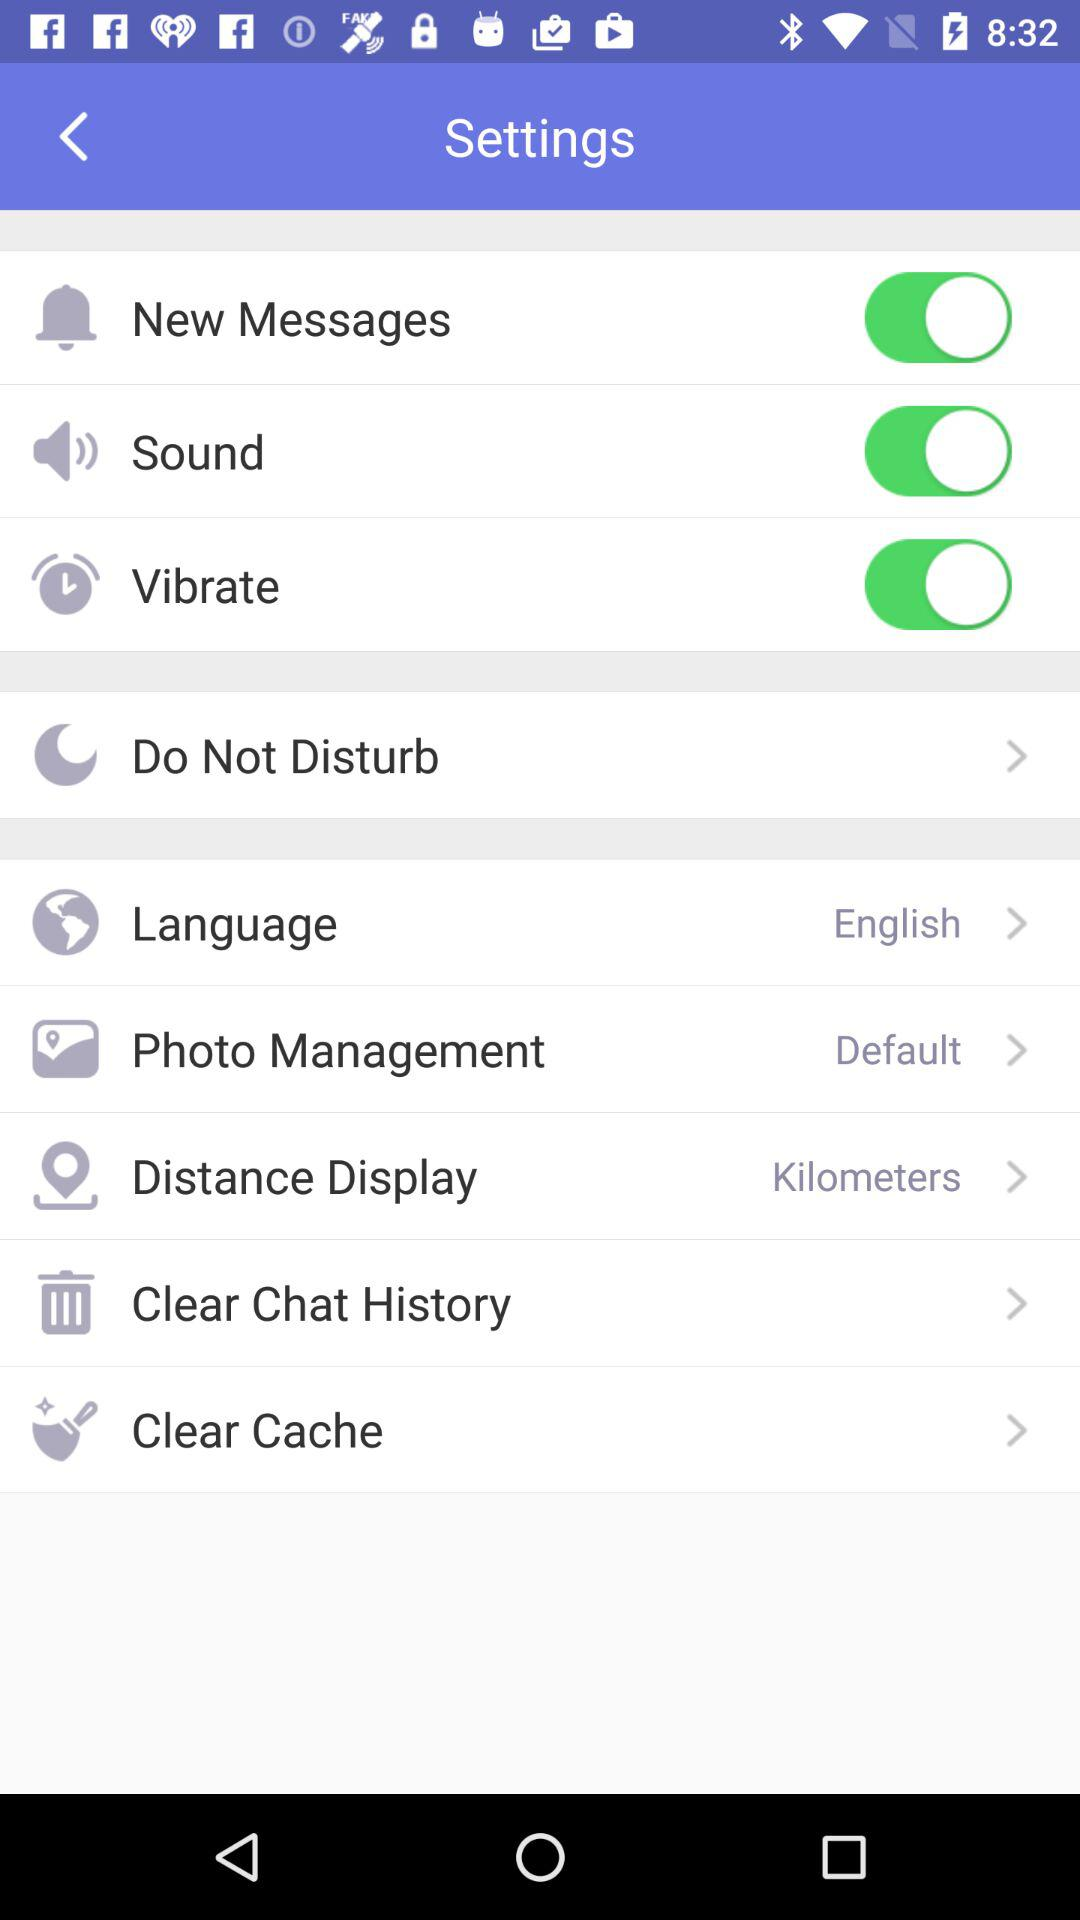Which option is selected for distance display? The selected option is "Kilometers". 